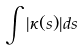Convert formula to latex. <formula><loc_0><loc_0><loc_500><loc_500>\int | \kappa ( s ) | d s</formula> 